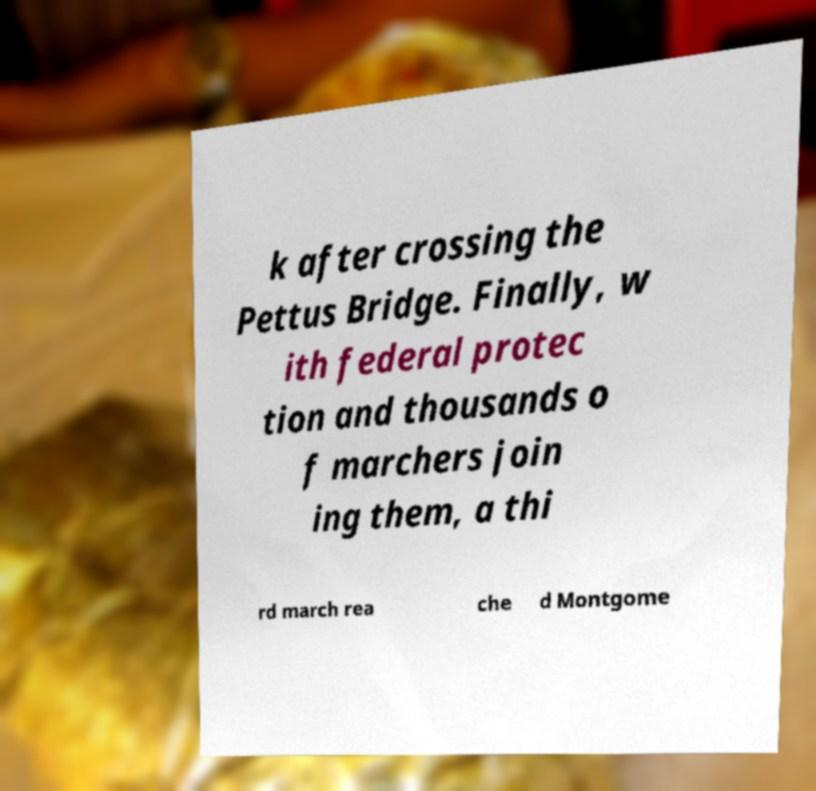Can you read and provide the text displayed in the image?This photo seems to have some interesting text. Can you extract and type it out for me? k after crossing the Pettus Bridge. Finally, w ith federal protec tion and thousands o f marchers join ing them, a thi rd march rea che d Montgome 